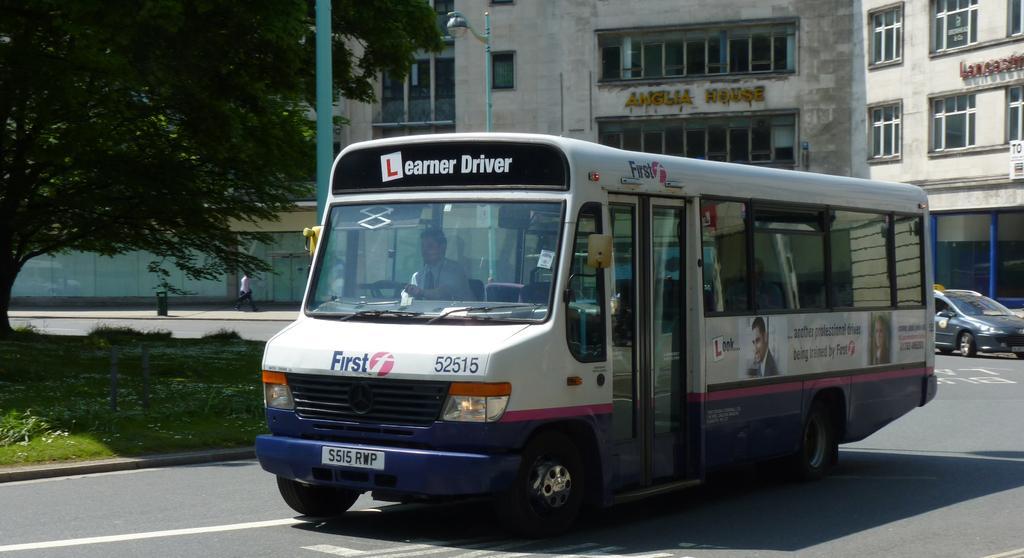Please provide a concise description of this image. In this image we can see a motor vehicle and a person in it on the road. In the background we can see grass, shrubs, tree, poles, street lights, buildings and name boards. 